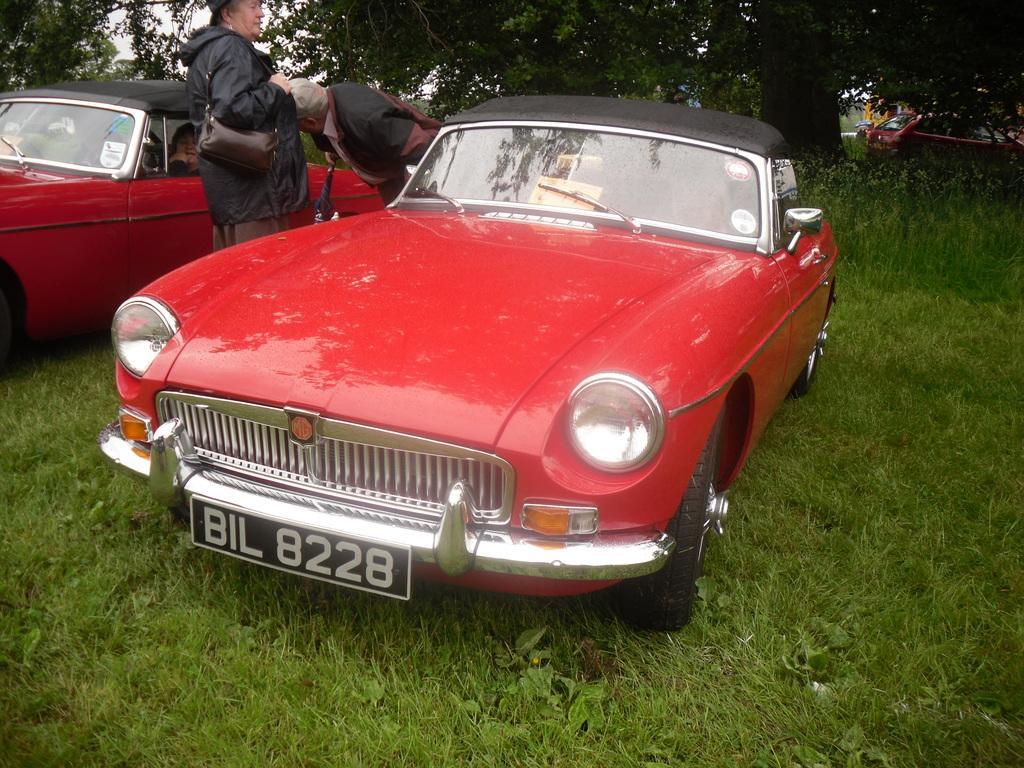In one or two sentences, can you explain what this image depicts? This picture is of outside. In the foreground we can see a red color car, beside that there are two persons standing and on the left corner we can see another red color car. In the background we can see the sky and the trees and also a car. 